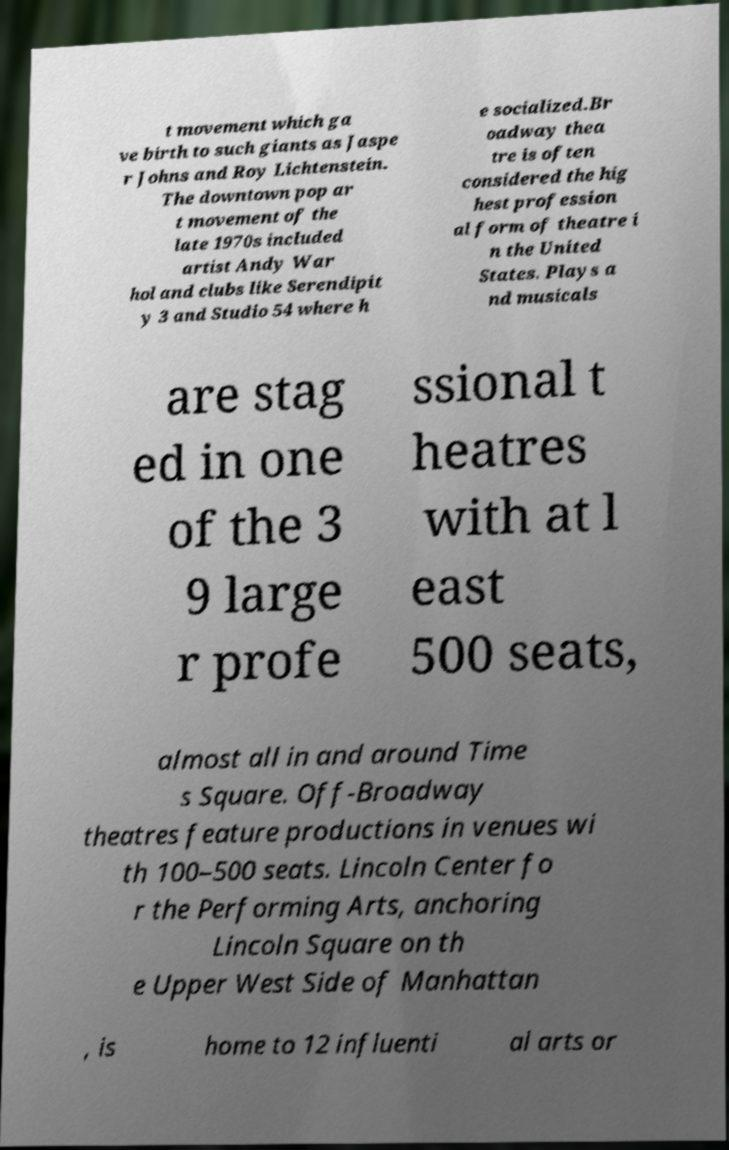There's text embedded in this image that I need extracted. Can you transcribe it verbatim? t movement which ga ve birth to such giants as Jaspe r Johns and Roy Lichtenstein. The downtown pop ar t movement of the late 1970s included artist Andy War hol and clubs like Serendipit y 3 and Studio 54 where h e socialized.Br oadway thea tre is often considered the hig hest profession al form of theatre i n the United States. Plays a nd musicals are stag ed in one of the 3 9 large r profe ssional t heatres with at l east 500 seats, almost all in and around Time s Square. Off-Broadway theatres feature productions in venues wi th 100–500 seats. Lincoln Center fo r the Performing Arts, anchoring Lincoln Square on th e Upper West Side of Manhattan , is home to 12 influenti al arts or 